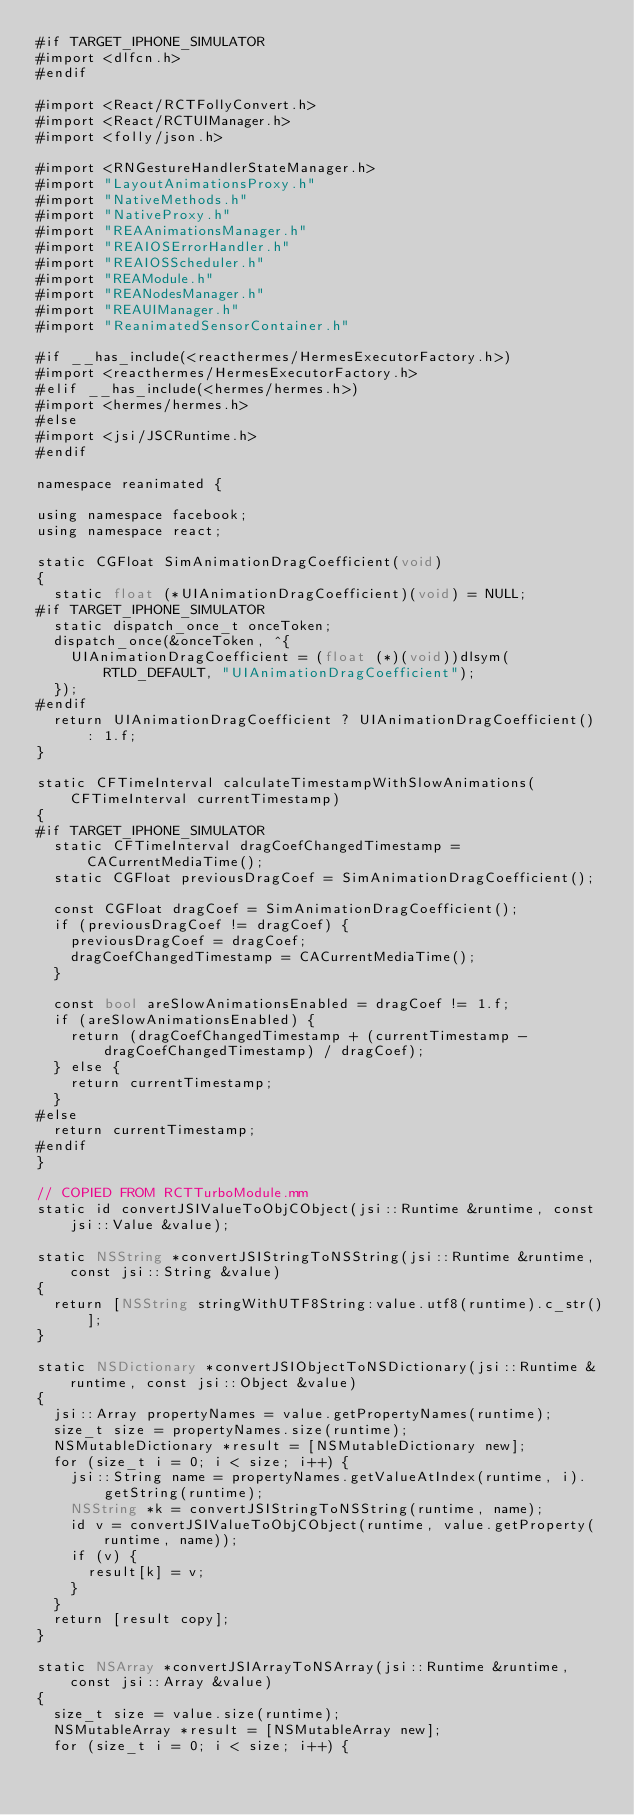<code> <loc_0><loc_0><loc_500><loc_500><_ObjectiveC_>#if TARGET_IPHONE_SIMULATOR
#import <dlfcn.h>
#endif

#import <React/RCTFollyConvert.h>
#import <React/RCTUIManager.h>
#import <folly/json.h>

#import <RNGestureHandlerStateManager.h>
#import "LayoutAnimationsProxy.h"
#import "NativeMethods.h"
#import "NativeProxy.h"
#import "REAAnimationsManager.h"
#import "REAIOSErrorHandler.h"
#import "REAIOSScheduler.h"
#import "REAModule.h"
#import "REANodesManager.h"
#import "REAUIManager.h"
#import "ReanimatedSensorContainer.h"

#if __has_include(<reacthermes/HermesExecutorFactory.h>)
#import <reacthermes/HermesExecutorFactory.h>
#elif __has_include(<hermes/hermes.h>)
#import <hermes/hermes.h>
#else
#import <jsi/JSCRuntime.h>
#endif

namespace reanimated {

using namespace facebook;
using namespace react;

static CGFloat SimAnimationDragCoefficient(void)
{
  static float (*UIAnimationDragCoefficient)(void) = NULL;
#if TARGET_IPHONE_SIMULATOR
  static dispatch_once_t onceToken;
  dispatch_once(&onceToken, ^{
    UIAnimationDragCoefficient = (float (*)(void))dlsym(RTLD_DEFAULT, "UIAnimationDragCoefficient");
  });
#endif
  return UIAnimationDragCoefficient ? UIAnimationDragCoefficient() : 1.f;
}

static CFTimeInterval calculateTimestampWithSlowAnimations(CFTimeInterval currentTimestamp)
{
#if TARGET_IPHONE_SIMULATOR
  static CFTimeInterval dragCoefChangedTimestamp = CACurrentMediaTime();
  static CGFloat previousDragCoef = SimAnimationDragCoefficient();

  const CGFloat dragCoef = SimAnimationDragCoefficient();
  if (previousDragCoef != dragCoef) {
    previousDragCoef = dragCoef;
    dragCoefChangedTimestamp = CACurrentMediaTime();
  }

  const bool areSlowAnimationsEnabled = dragCoef != 1.f;
  if (areSlowAnimationsEnabled) {
    return (dragCoefChangedTimestamp + (currentTimestamp - dragCoefChangedTimestamp) / dragCoef);
  } else {
    return currentTimestamp;
  }
#else
  return currentTimestamp;
#endif
}

// COPIED FROM RCTTurboModule.mm
static id convertJSIValueToObjCObject(jsi::Runtime &runtime, const jsi::Value &value);

static NSString *convertJSIStringToNSString(jsi::Runtime &runtime, const jsi::String &value)
{
  return [NSString stringWithUTF8String:value.utf8(runtime).c_str()];
}

static NSDictionary *convertJSIObjectToNSDictionary(jsi::Runtime &runtime, const jsi::Object &value)
{
  jsi::Array propertyNames = value.getPropertyNames(runtime);
  size_t size = propertyNames.size(runtime);
  NSMutableDictionary *result = [NSMutableDictionary new];
  for (size_t i = 0; i < size; i++) {
    jsi::String name = propertyNames.getValueAtIndex(runtime, i).getString(runtime);
    NSString *k = convertJSIStringToNSString(runtime, name);
    id v = convertJSIValueToObjCObject(runtime, value.getProperty(runtime, name));
    if (v) {
      result[k] = v;
    }
  }
  return [result copy];
}

static NSArray *convertJSIArrayToNSArray(jsi::Runtime &runtime, const jsi::Array &value)
{
  size_t size = value.size(runtime);
  NSMutableArray *result = [NSMutableArray new];
  for (size_t i = 0; i < size; i++) {</code> 